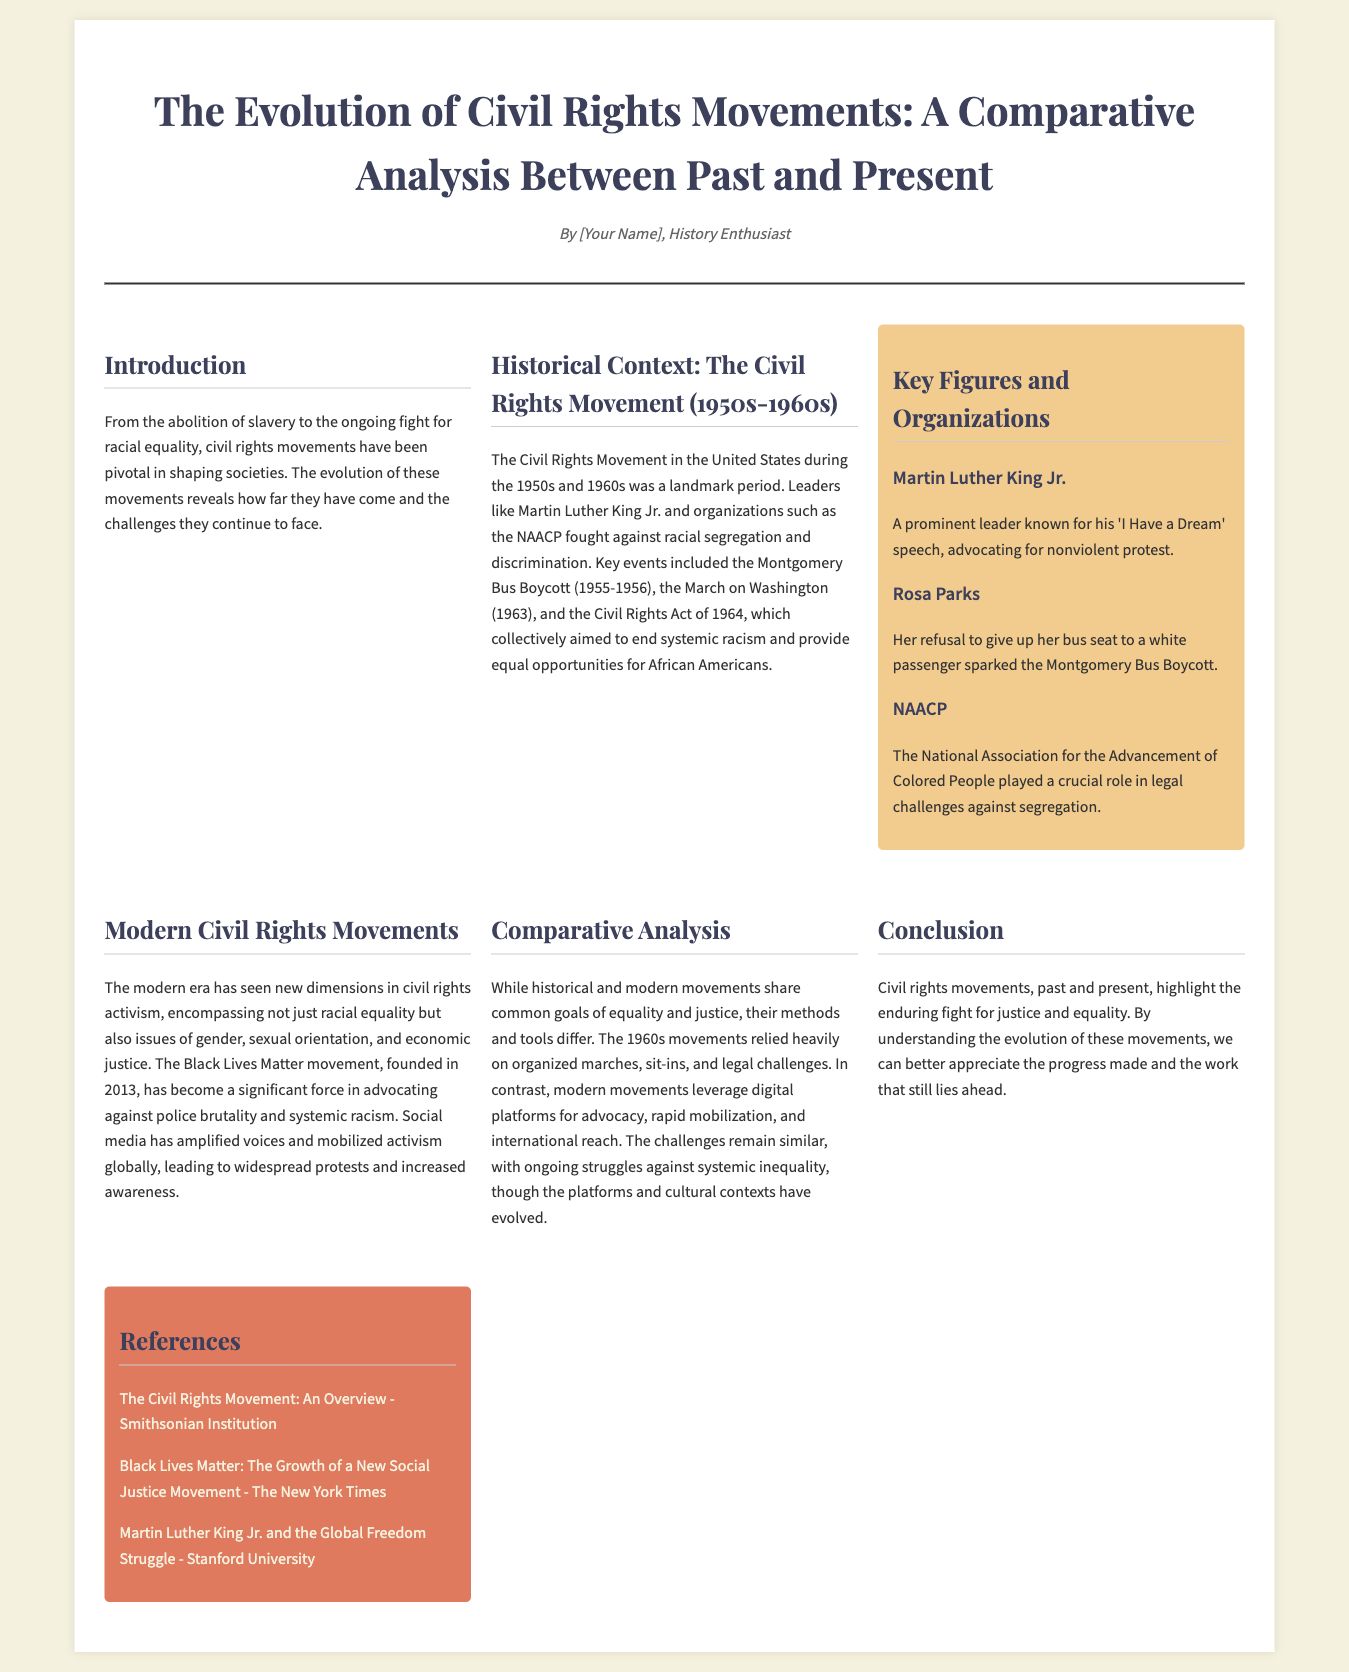what's the title of the document? The title summarizes the main topic the document addresses, which is found in the header.
Answer: The Evolution of Civil Rights Movements: A Comparative Analysis Between Past and Present who was a prominent leader during the Civil Rights Movement? The key figures section lists influential individuals from the historical context.
Answer: Martin Luther King Jr what organization played a crucial role in legal challenges against segregation? The key figures section provides details about significant organizations during the Civil Rights Movement.
Answer: NAACP when did the Montgomery Bus Boycott take place? The historical context section mentions the time frame of this significant event.
Answer: 1955-1956 which modern movement advocates against police brutality? The modern civil rights movements section discusses contemporary activism.
Answer: Black Lives Matter how do modern civil rights movements differ from historical ones in their mobilization strategies? The comparative analysis section explains the evolution of methods used in civil rights activism over time.
Answer: Digital platforms what is the main focus of the conclusion section? The conclusion summarizes the overarching themes and messages from the document.
Answer: The enduring fight for justice and equality 